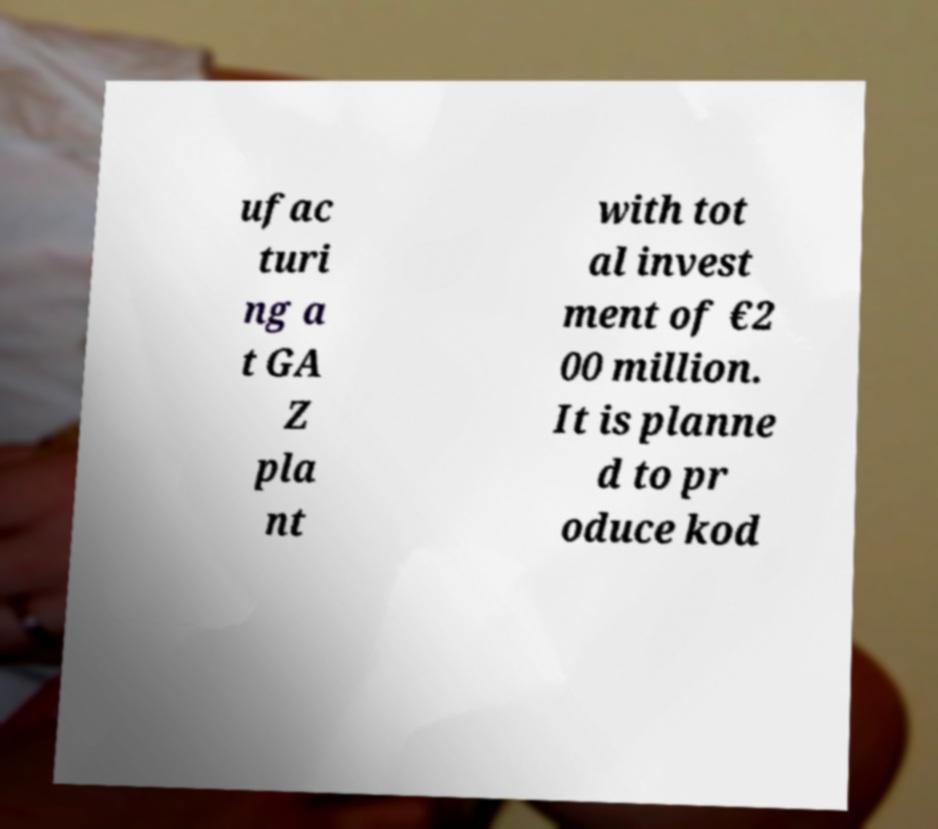Please identify and transcribe the text found in this image. ufac turi ng a t GA Z pla nt with tot al invest ment of €2 00 million. It is planne d to pr oduce kod 